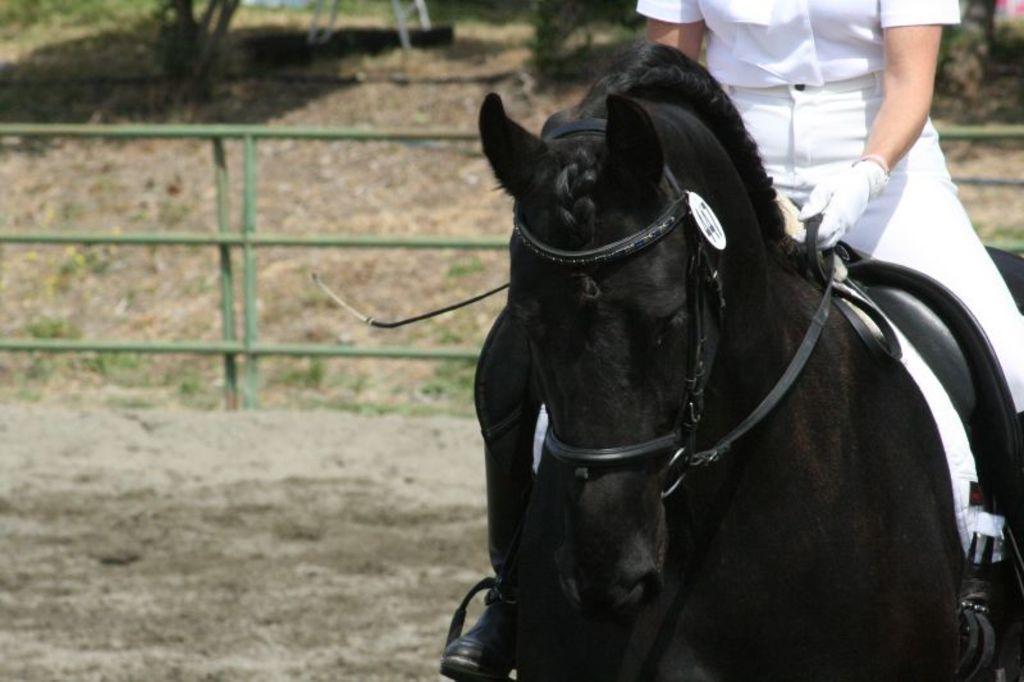Could you give a brief overview of what you see in this image? In this image I can see a horse on the right hand side and a person sitting on the horse. I can see some fencing behind on the ground. The background is blurred. 